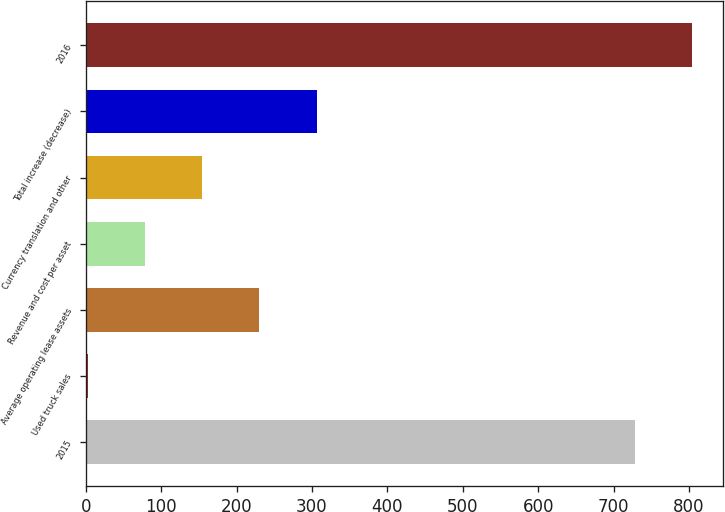<chart> <loc_0><loc_0><loc_500><loc_500><bar_chart><fcel>2015<fcel>Used truck sales<fcel>Average operating lease assets<fcel>Revenue and cost per asset<fcel>Currency translation and other<fcel>Total increase (decrease)<fcel>2016<nl><fcel>728.5<fcel>3.2<fcel>230.39<fcel>78.93<fcel>154.66<fcel>306.12<fcel>804.23<nl></chart> 